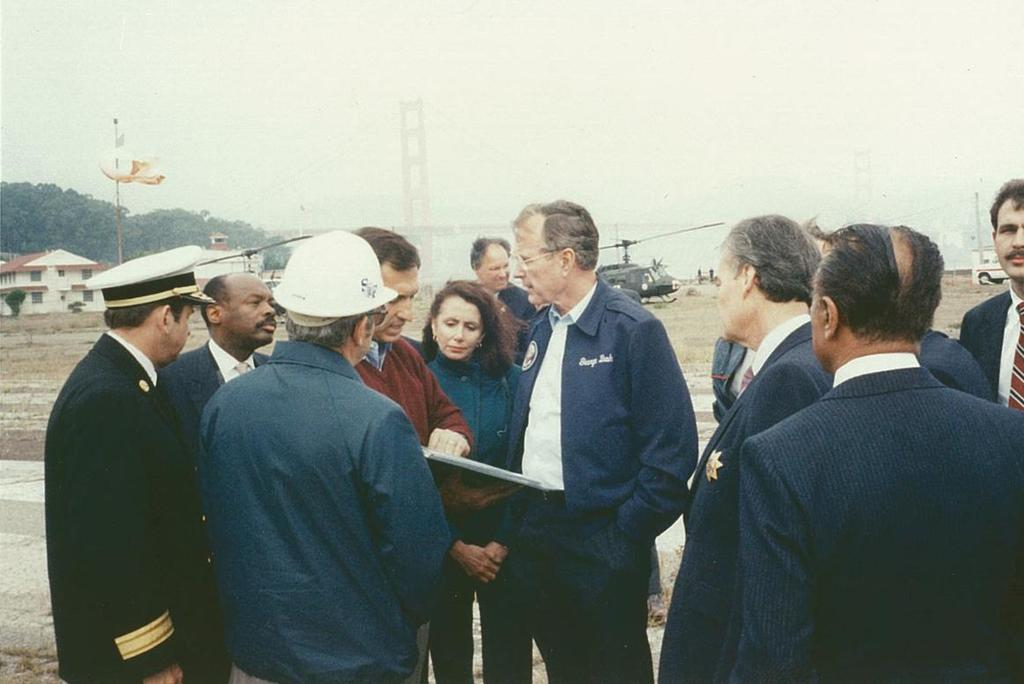What can be seen in the image? There is a group of people in the image. What is visible in the background of the image? In the background, there are poles, a helicopter, a house, trees, and the sky. Can you describe the setting of the image? The image appears to be set in an outdoor area with a mix of natural and man-made elements. What type of sweater is the pail wearing in the image? There is no pail or sweater present in the image. 